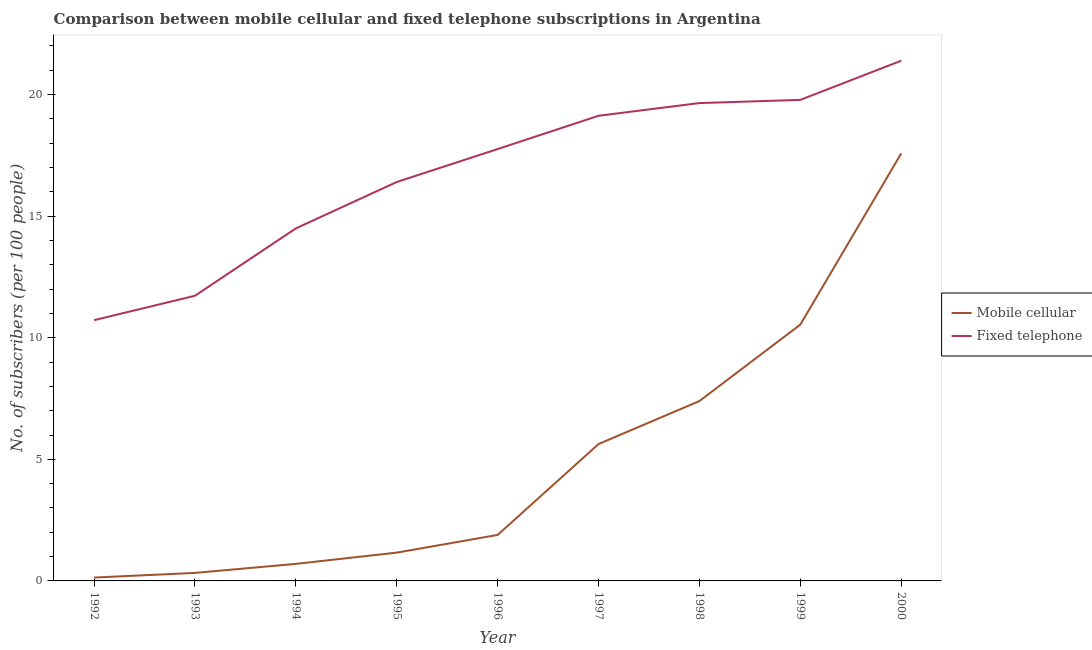What is the number of fixed telephone subscribers in 1998?
Your answer should be compact. 19.65. Across all years, what is the maximum number of mobile cellular subscribers?
Provide a short and direct response. 17.58. Across all years, what is the minimum number of fixed telephone subscribers?
Provide a short and direct response. 10.72. What is the total number of fixed telephone subscribers in the graph?
Keep it short and to the point. 151.06. What is the difference between the number of fixed telephone subscribers in 1992 and that in 1994?
Provide a short and direct response. -3.77. What is the difference between the number of mobile cellular subscribers in 1999 and the number of fixed telephone subscribers in 1995?
Provide a short and direct response. -5.86. What is the average number of fixed telephone subscribers per year?
Ensure brevity in your answer.  16.78. In the year 1996, what is the difference between the number of fixed telephone subscribers and number of mobile cellular subscribers?
Offer a very short reply. 15.87. In how many years, is the number of fixed telephone subscribers greater than 20?
Your response must be concise. 1. What is the ratio of the number of mobile cellular subscribers in 1996 to that in 1998?
Your response must be concise. 0.26. Is the number of mobile cellular subscribers in 1997 less than that in 1999?
Your response must be concise. Yes. Is the difference between the number of mobile cellular subscribers in 1992 and 1996 greater than the difference between the number of fixed telephone subscribers in 1992 and 1996?
Keep it short and to the point. Yes. What is the difference between the highest and the second highest number of fixed telephone subscribers?
Offer a terse response. 1.61. What is the difference between the highest and the lowest number of fixed telephone subscribers?
Make the answer very short. 10.67. In how many years, is the number of mobile cellular subscribers greater than the average number of mobile cellular subscribers taken over all years?
Your answer should be compact. 4. How many lines are there?
Give a very brief answer. 2. How many years are there in the graph?
Offer a terse response. 9. Are the values on the major ticks of Y-axis written in scientific E-notation?
Offer a terse response. No. Does the graph contain any zero values?
Offer a very short reply. No. How many legend labels are there?
Your answer should be compact. 2. What is the title of the graph?
Offer a terse response. Comparison between mobile cellular and fixed telephone subscriptions in Argentina. What is the label or title of the Y-axis?
Offer a terse response. No. of subscribers (per 100 people). What is the No. of subscribers (per 100 people) in Mobile cellular in 1992?
Provide a short and direct response. 0.14. What is the No. of subscribers (per 100 people) in Fixed telephone in 1992?
Offer a terse response. 10.72. What is the No. of subscribers (per 100 people) of Mobile cellular in 1993?
Your answer should be very brief. 0.33. What is the No. of subscribers (per 100 people) of Fixed telephone in 1993?
Your response must be concise. 11.73. What is the No. of subscribers (per 100 people) in Mobile cellular in 1994?
Make the answer very short. 0.7. What is the No. of subscribers (per 100 people) in Fixed telephone in 1994?
Give a very brief answer. 14.5. What is the No. of subscribers (per 100 people) of Mobile cellular in 1995?
Offer a terse response. 1.16. What is the No. of subscribers (per 100 people) of Fixed telephone in 1995?
Offer a very short reply. 16.4. What is the No. of subscribers (per 100 people) in Mobile cellular in 1996?
Your response must be concise. 1.89. What is the No. of subscribers (per 100 people) of Fixed telephone in 1996?
Your response must be concise. 17.76. What is the No. of subscribers (per 100 people) in Mobile cellular in 1997?
Ensure brevity in your answer.  5.63. What is the No. of subscribers (per 100 people) of Fixed telephone in 1997?
Provide a short and direct response. 19.13. What is the No. of subscribers (per 100 people) of Mobile cellular in 1998?
Offer a very short reply. 7.4. What is the No. of subscribers (per 100 people) in Fixed telephone in 1998?
Your answer should be compact. 19.65. What is the No. of subscribers (per 100 people) in Mobile cellular in 1999?
Provide a succinct answer. 10.54. What is the No. of subscribers (per 100 people) of Fixed telephone in 1999?
Offer a very short reply. 19.78. What is the No. of subscribers (per 100 people) in Mobile cellular in 2000?
Your answer should be compact. 17.58. What is the No. of subscribers (per 100 people) of Fixed telephone in 2000?
Your answer should be very brief. 21.39. Across all years, what is the maximum No. of subscribers (per 100 people) of Mobile cellular?
Your answer should be very brief. 17.58. Across all years, what is the maximum No. of subscribers (per 100 people) of Fixed telephone?
Make the answer very short. 21.39. Across all years, what is the minimum No. of subscribers (per 100 people) of Mobile cellular?
Your response must be concise. 0.14. Across all years, what is the minimum No. of subscribers (per 100 people) in Fixed telephone?
Keep it short and to the point. 10.72. What is the total No. of subscribers (per 100 people) in Mobile cellular in the graph?
Offer a terse response. 45.37. What is the total No. of subscribers (per 100 people) in Fixed telephone in the graph?
Your answer should be very brief. 151.06. What is the difference between the No. of subscribers (per 100 people) in Mobile cellular in 1992 and that in 1993?
Your response must be concise. -0.19. What is the difference between the No. of subscribers (per 100 people) of Fixed telephone in 1992 and that in 1993?
Give a very brief answer. -1. What is the difference between the No. of subscribers (per 100 people) in Mobile cellular in 1992 and that in 1994?
Your response must be concise. -0.56. What is the difference between the No. of subscribers (per 100 people) in Fixed telephone in 1992 and that in 1994?
Make the answer very short. -3.77. What is the difference between the No. of subscribers (per 100 people) in Mobile cellular in 1992 and that in 1995?
Offer a very short reply. -1.02. What is the difference between the No. of subscribers (per 100 people) in Fixed telephone in 1992 and that in 1995?
Make the answer very short. -5.68. What is the difference between the No. of subscribers (per 100 people) of Mobile cellular in 1992 and that in 1996?
Offer a terse response. -1.75. What is the difference between the No. of subscribers (per 100 people) of Fixed telephone in 1992 and that in 1996?
Offer a very short reply. -7.04. What is the difference between the No. of subscribers (per 100 people) of Mobile cellular in 1992 and that in 1997?
Keep it short and to the point. -5.49. What is the difference between the No. of subscribers (per 100 people) of Fixed telephone in 1992 and that in 1997?
Make the answer very short. -8.4. What is the difference between the No. of subscribers (per 100 people) in Mobile cellular in 1992 and that in 1998?
Your answer should be compact. -7.26. What is the difference between the No. of subscribers (per 100 people) of Fixed telephone in 1992 and that in 1998?
Make the answer very short. -8.93. What is the difference between the No. of subscribers (per 100 people) in Mobile cellular in 1992 and that in 1999?
Provide a succinct answer. -10.4. What is the difference between the No. of subscribers (per 100 people) of Fixed telephone in 1992 and that in 1999?
Your response must be concise. -9.06. What is the difference between the No. of subscribers (per 100 people) in Mobile cellular in 1992 and that in 2000?
Keep it short and to the point. -17.44. What is the difference between the No. of subscribers (per 100 people) in Fixed telephone in 1992 and that in 2000?
Provide a succinct answer. -10.67. What is the difference between the No. of subscribers (per 100 people) in Mobile cellular in 1993 and that in 1994?
Offer a very short reply. -0.37. What is the difference between the No. of subscribers (per 100 people) in Fixed telephone in 1993 and that in 1994?
Ensure brevity in your answer.  -2.77. What is the difference between the No. of subscribers (per 100 people) of Mobile cellular in 1993 and that in 1995?
Ensure brevity in your answer.  -0.83. What is the difference between the No. of subscribers (per 100 people) in Fixed telephone in 1993 and that in 1995?
Provide a short and direct response. -4.68. What is the difference between the No. of subscribers (per 100 people) of Mobile cellular in 1993 and that in 1996?
Your answer should be very brief. -1.56. What is the difference between the No. of subscribers (per 100 people) of Fixed telephone in 1993 and that in 1996?
Provide a succinct answer. -6.03. What is the difference between the No. of subscribers (per 100 people) of Mobile cellular in 1993 and that in 1997?
Provide a succinct answer. -5.3. What is the difference between the No. of subscribers (per 100 people) of Fixed telephone in 1993 and that in 1997?
Your answer should be compact. -7.4. What is the difference between the No. of subscribers (per 100 people) in Mobile cellular in 1993 and that in 1998?
Keep it short and to the point. -7.07. What is the difference between the No. of subscribers (per 100 people) of Fixed telephone in 1993 and that in 1998?
Provide a short and direct response. -7.92. What is the difference between the No. of subscribers (per 100 people) of Mobile cellular in 1993 and that in 1999?
Ensure brevity in your answer.  -10.21. What is the difference between the No. of subscribers (per 100 people) in Fixed telephone in 1993 and that in 1999?
Offer a terse response. -8.06. What is the difference between the No. of subscribers (per 100 people) in Mobile cellular in 1993 and that in 2000?
Ensure brevity in your answer.  -17.25. What is the difference between the No. of subscribers (per 100 people) of Fixed telephone in 1993 and that in 2000?
Your response must be concise. -9.67. What is the difference between the No. of subscribers (per 100 people) in Mobile cellular in 1994 and that in 1995?
Keep it short and to the point. -0.46. What is the difference between the No. of subscribers (per 100 people) of Fixed telephone in 1994 and that in 1995?
Your answer should be very brief. -1.91. What is the difference between the No. of subscribers (per 100 people) of Mobile cellular in 1994 and that in 1996?
Your answer should be very brief. -1.19. What is the difference between the No. of subscribers (per 100 people) in Fixed telephone in 1994 and that in 1996?
Provide a short and direct response. -3.26. What is the difference between the No. of subscribers (per 100 people) in Mobile cellular in 1994 and that in 1997?
Your response must be concise. -4.93. What is the difference between the No. of subscribers (per 100 people) of Fixed telephone in 1994 and that in 1997?
Your response must be concise. -4.63. What is the difference between the No. of subscribers (per 100 people) of Mobile cellular in 1994 and that in 1998?
Your answer should be very brief. -6.7. What is the difference between the No. of subscribers (per 100 people) of Fixed telephone in 1994 and that in 1998?
Your answer should be very brief. -5.15. What is the difference between the No. of subscribers (per 100 people) of Mobile cellular in 1994 and that in 1999?
Your answer should be compact. -9.84. What is the difference between the No. of subscribers (per 100 people) in Fixed telephone in 1994 and that in 1999?
Ensure brevity in your answer.  -5.28. What is the difference between the No. of subscribers (per 100 people) of Mobile cellular in 1994 and that in 2000?
Provide a short and direct response. -16.88. What is the difference between the No. of subscribers (per 100 people) of Fixed telephone in 1994 and that in 2000?
Keep it short and to the point. -6.89. What is the difference between the No. of subscribers (per 100 people) of Mobile cellular in 1995 and that in 1996?
Offer a terse response. -0.73. What is the difference between the No. of subscribers (per 100 people) of Fixed telephone in 1995 and that in 1996?
Your response must be concise. -1.35. What is the difference between the No. of subscribers (per 100 people) of Mobile cellular in 1995 and that in 1997?
Your answer should be very brief. -4.47. What is the difference between the No. of subscribers (per 100 people) in Fixed telephone in 1995 and that in 1997?
Provide a succinct answer. -2.72. What is the difference between the No. of subscribers (per 100 people) in Mobile cellular in 1995 and that in 1998?
Make the answer very short. -6.23. What is the difference between the No. of subscribers (per 100 people) of Fixed telephone in 1995 and that in 1998?
Keep it short and to the point. -3.25. What is the difference between the No. of subscribers (per 100 people) in Mobile cellular in 1995 and that in 1999?
Your answer should be very brief. -9.38. What is the difference between the No. of subscribers (per 100 people) in Fixed telephone in 1995 and that in 1999?
Keep it short and to the point. -3.38. What is the difference between the No. of subscribers (per 100 people) in Mobile cellular in 1995 and that in 2000?
Your answer should be very brief. -16.42. What is the difference between the No. of subscribers (per 100 people) of Fixed telephone in 1995 and that in 2000?
Ensure brevity in your answer.  -4.99. What is the difference between the No. of subscribers (per 100 people) in Mobile cellular in 1996 and that in 1997?
Offer a very short reply. -3.74. What is the difference between the No. of subscribers (per 100 people) of Fixed telephone in 1996 and that in 1997?
Give a very brief answer. -1.37. What is the difference between the No. of subscribers (per 100 people) of Mobile cellular in 1996 and that in 1998?
Your response must be concise. -5.51. What is the difference between the No. of subscribers (per 100 people) in Fixed telephone in 1996 and that in 1998?
Ensure brevity in your answer.  -1.89. What is the difference between the No. of subscribers (per 100 people) of Mobile cellular in 1996 and that in 1999?
Make the answer very short. -8.65. What is the difference between the No. of subscribers (per 100 people) in Fixed telephone in 1996 and that in 1999?
Make the answer very short. -2.02. What is the difference between the No. of subscribers (per 100 people) of Mobile cellular in 1996 and that in 2000?
Offer a terse response. -15.69. What is the difference between the No. of subscribers (per 100 people) in Fixed telephone in 1996 and that in 2000?
Give a very brief answer. -3.63. What is the difference between the No. of subscribers (per 100 people) of Mobile cellular in 1997 and that in 1998?
Give a very brief answer. -1.77. What is the difference between the No. of subscribers (per 100 people) in Fixed telephone in 1997 and that in 1998?
Your answer should be very brief. -0.52. What is the difference between the No. of subscribers (per 100 people) of Mobile cellular in 1997 and that in 1999?
Provide a succinct answer. -4.91. What is the difference between the No. of subscribers (per 100 people) in Fixed telephone in 1997 and that in 1999?
Make the answer very short. -0.65. What is the difference between the No. of subscribers (per 100 people) in Mobile cellular in 1997 and that in 2000?
Ensure brevity in your answer.  -11.95. What is the difference between the No. of subscribers (per 100 people) of Fixed telephone in 1997 and that in 2000?
Make the answer very short. -2.26. What is the difference between the No. of subscribers (per 100 people) of Mobile cellular in 1998 and that in 1999?
Keep it short and to the point. -3.14. What is the difference between the No. of subscribers (per 100 people) in Fixed telephone in 1998 and that in 1999?
Your response must be concise. -0.13. What is the difference between the No. of subscribers (per 100 people) of Mobile cellular in 1998 and that in 2000?
Your answer should be compact. -10.18. What is the difference between the No. of subscribers (per 100 people) of Fixed telephone in 1998 and that in 2000?
Make the answer very short. -1.74. What is the difference between the No. of subscribers (per 100 people) of Mobile cellular in 1999 and that in 2000?
Provide a short and direct response. -7.04. What is the difference between the No. of subscribers (per 100 people) in Fixed telephone in 1999 and that in 2000?
Give a very brief answer. -1.61. What is the difference between the No. of subscribers (per 100 people) of Mobile cellular in 1992 and the No. of subscribers (per 100 people) of Fixed telephone in 1993?
Offer a terse response. -11.59. What is the difference between the No. of subscribers (per 100 people) in Mobile cellular in 1992 and the No. of subscribers (per 100 people) in Fixed telephone in 1994?
Ensure brevity in your answer.  -14.36. What is the difference between the No. of subscribers (per 100 people) of Mobile cellular in 1992 and the No. of subscribers (per 100 people) of Fixed telephone in 1995?
Give a very brief answer. -16.27. What is the difference between the No. of subscribers (per 100 people) of Mobile cellular in 1992 and the No. of subscribers (per 100 people) of Fixed telephone in 1996?
Make the answer very short. -17.62. What is the difference between the No. of subscribers (per 100 people) of Mobile cellular in 1992 and the No. of subscribers (per 100 people) of Fixed telephone in 1997?
Your answer should be compact. -18.99. What is the difference between the No. of subscribers (per 100 people) of Mobile cellular in 1992 and the No. of subscribers (per 100 people) of Fixed telephone in 1998?
Offer a very short reply. -19.51. What is the difference between the No. of subscribers (per 100 people) of Mobile cellular in 1992 and the No. of subscribers (per 100 people) of Fixed telephone in 1999?
Keep it short and to the point. -19.64. What is the difference between the No. of subscribers (per 100 people) in Mobile cellular in 1992 and the No. of subscribers (per 100 people) in Fixed telephone in 2000?
Your response must be concise. -21.25. What is the difference between the No. of subscribers (per 100 people) in Mobile cellular in 1993 and the No. of subscribers (per 100 people) in Fixed telephone in 1994?
Your answer should be compact. -14.17. What is the difference between the No. of subscribers (per 100 people) of Mobile cellular in 1993 and the No. of subscribers (per 100 people) of Fixed telephone in 1995?
Give a very brief answer. -16.07. What is the difference between the No. of subscribers (per 100 people) of Mobile cellular in 1993 and the No. of subscribers (per 100 people) of Fixed telephone in 1996?
Keep it short and to the point. -17.43. What is the difference between the No. of subscribers (per 100 people) of Mobile cellular in 1993 and the No. of subscribers (per 100 people) of Fixed telephone in 1997?
Ensure brevity in your answer.  -18.8. What is the difference between the No. of subscribers (per 100 people) of Mobile cellular in 1993 and the No. of subscribers (per 100 people) of Fixed telephone in 1998?
Make the answer very short. -19.32. What is the difference between the No. of subscribers (per 100 people) of Mobile cellular in 1993 and the No. of subscribers (per 100 people) of Fixed telephone in 1999?
Provide a short and direct response. -19.45. What is the difference between the No. of subscribers (per 100 people) of Mobile cellular in 1993 and the No. of subscribers (per 100 people) of Fixed telephone in 2000?
Give a very brief answer. -21.06. What is the difference between the No. of subscribers (per 100 people) in Mobile cellular in 1994 and the No. of subscribers (per 100 people) in Fixed telephone in 1995?
Ensure brevity in your answer.  -15.7. What is the difference between the No. of subscribers (per 100 people) in Mobile cellular in 1994 and the No. of subscribers (per 100 people) in Fixed telephone in 1996?
Keep it short and to the point. -17.06. What is the difference between the No. of subscribers (per 100 people) of Mobile cellular in 1994 and the No. of subscribers (per 100 people) of Fixed telephone in 1997?
Make the answer very short. -18.43. What is the difference between the No. of subscribers (per 100 people) of Mobile cellular in 1994 and the No. of subscribers (per 100 people) of Fixed telephone in 1998?
Provide a short and direct response. -18.95. What is the difference between the No. of subscribers (per 100 people) of Mobile cellular in 1994 and the No. of subscribers (per 100 people) of Fixed telephone in 1999?
Ensure brevity in your answer.  -19.08. What is the difference between the No. of subscribers (per 100 people) in Mobile cellular in 1994 and the No. of subscribers (per 100 people) in Fixed telephone in 2000?
Make the answer very short. -20.69. What is the difference between the No. of subscribers (per 100 people) in Mobile cellular in 1995 and the No. of subscribers (per 100 people) in Fixed telephone in 1996?
Your answer should be very brief. -16.6. What is the difference between the No. of subscribers (per 100 people) of Mobile cellular in 1995 and the No. of subscribers (per 100 people) of Fixed telephone in 1997?
Your answer should be very brief. -17.96. What is the difference between the No. of subscribers (per 100 people) in Mobile cellular in 1995 and the No. of subscribers (per 100 people) in Fixed telephone in 1998?
Offer a terse response. -18.49. What is the difference between the No. of subscribers (per 100 people) in Mobile cellular in 1995 and the No. of subscribers (per 100 people) in Fixed telephone in 1999?
Provide a short and direct response. -18.62. What is the difference between the No. of subscribers (per 100 people) in Mobile cellular in 1995 and the No. of subscribers (per 100 people) in Fixed telephone in 2000?
Provide a short and direct response. -20.23. What is the difference between the No. of subscribers (per 100 people) of Mobile cellular in 1996 and the No. of subscribers (per 100 people) of Fixed telephone in 1997?
Keep it short and to the point. -17.24. What is the difference between the No. of subscribers (per 100 people) in Mobile cellular in 1996 and the No. of subscribers (per 100 people) in Fixed telephone in 1998?
Make the answer very short. -17.76. What is the difference between the No. of subscribers (per 100 people) of Mobile cellular in 1996 and the No. of subscribers (per 100 people) of Fixed telephone in 1999?
Your answer should be very brief. -17.89. What is the difference between the No. of subscribers (per 100 people) of Mobile cellular in 1996 and the No. of subscribers (per 100 people) of Fixed telephone in 2000?
Your response must be concise. -19.5. What is the difference between the No. of subscribers (per 100 people) of Mobile cellular in 1997 and the No. of subscribers (per 100 people) of Fixed telephone in 1998?
Provide a short and direct response. -14.02. What is the difference between the No. of subscribers (per 100 people) in Mobile cellular in 1997 and the No. of subscribers (per 100 people) in Fixed telephone in 1999?
Offer a very short reply. -14.15. What is the difference between the No. of subscribers (per 100 people) in Mobile cellular in 1997 and the No. of subscribers (per 100 people) in Fixed telephone in 2000?
Your answer should be very brief. -15.76. What is the difference between the No. of subscribers (per 100 people) in Mobile cellular in 1998 and the No. of subscribers (per 100 people) in Fixed telephone in 1999?
Keep it short and to the point. -12.38. What is the difference between the No. of subscribers (per 100 people) of Mobile cellular in 1998 and the No. of subscribers (per 100 people) of Fixed telephone in 2000?
Your response must be concise. -14. What is the difference between the No. of subscribers (per 100 people) of Mobile cellular in 1999 and the No. of subscribers (per 100 people) of Fixed telephone in 2000?
Provide a short and direct response. -10.85. What is the average No. of subscribers (per 100 people) of Mobile cellular per year?
Offer a terse response. 5.04. What is the average No. of subscribers (per 100 people) of Fixed telephone per year?
Offer a very short reply. 16.78. In the year 1992, what is the difference between the No. of subscribers (per 100 people) of Mobile cellular and No. of subscribers (per 100 people) of Fixed telephone?
Your response must be concise. -10.58. In the year 1993, what is the difference between the No. of subscribers (per 100 people) in Mobile cellular and No. of subscribers (per 100 people) in Fixed telephone?
Give a very brief answer. -11.4. In the year 1994, what is the difference between the No. of subscribers (per 100 people) in Mobile cellular and No. of subscribers (per 100 people) in Fixed telephone?
Your answer should be compact. -13.8. In the year 1995, what is the difference between the No. of subscribers (per 100 people) of Mobile cellular and No. of subscribers (per 100 people) of Fixed telephone?
Your answer should be very brief. -15.24. In the year 1996, what is the difference between the No. of subscribers (per 100 people) in Mobile cellular and No. of subscribers (per 100 people) in Fixed telephone?
Keep it short and to the point. -15.87. In the year 1997, what is the difference between the No. of subscribers (per 100 people) of Mobile cellular and No. of subscribers (per 100 people) of Fixed telephone?
Provide a short and direct response. -13.5. In the year 1998, what is the difference between the No. of subscribers (per 100 people) in Mobile cellular and No. of subscribers (per 100 people) in Fixed telephone?
Offer a very short reply. -12.25. In the year 1999, what is the difference between the No. of subscribers (per 100 people) in Mobile cellular and No. of subscribers (per 100 people) in Fixed telephone?
Provide a succinct answer. -9.24. In the year 2000, what is the difference between the No. of subscribers (per 100 people) in Mobile cellular and No. of subscribers (per 100 people) in Fixed telephone?
Your answer should be compact. -3.81. What is the ratio of the No. of subscribers (per 100 people) of Mobile cellular in 1992 to that in 1993?
Offer a very short reply. 0.42. What is the ratio of the No. of subscribers (per 100 people) of Fixed telephone in 1992 to that in 1993?
Provide a succinct answer. 0.91. What is the ratio of the No. of subscribers (per 100 people) of Mobile cellular in 1992 to that in 1994?
Provide a short and direct response. 0.2. What is the ratio of the No. of subscribers (per 100 people) in Fixed telephone in 1992 to that in 1994?
Make the answer very short. 0.74. What is the ratio of the No. of subscribers (per 100 people) of Mobile cellular in 1992 to that in 1995?
Your response must be concise. 0.12. What is the ratio of the No. of subscribers (per 100 people) of Fixed telephone in 1992 to that in 1995?
Keep it short and to the point. 0.65. What is the ratio of the No. of subscribers (per 100 people) of Mobile cellular in 1992 to that in 1996?
Your answer should be compact. 0.07. What is the ratio of the No. of subscribers (per 100 people) in Fixed telephone in 1992 to that in 1996?
Offer a very short reply. 0.6. What is the ratio of the No. of subscribers (per 100 people) of Mobile cellular in 1992 to that in 1997?
Ensure brevity in your answer.  0.02. What is the ratio of the No. of subscribers (per 100 people) of Fixed telephone in 1992 to that in 1997?
Your response must be concise. 0.56. What is the ratio of the No. of subscribers (per 100 people) of Mobile cellular in 1992 to that in 1998?
Provide a succinct answer. 0.02. What is the ratio of the No. of subscribers (per 100 people) in Fixed telephone in 1992 to that in 1998?
Provide a succinct answer. 0.55. What is the ratio of the No. of subscribers (per 100 people) of Mobile cellular in 1992 to that in 1999?
Your response must be concise. 0.01. What is the ratio of the No. of subscribers (per 100 people) in Fixed telephone in 1992 to that in 1999?
Provide a short and direct response. 0.54. What is the ratio of the No. of subscribers (per 100 people) of Mobile cellular in 1992 to that in 2000?
Your answer should be compact. 0.01. What is the ratio of the No. of subscribers (per 100 people) of Fixed telephone in 1992 to that in 2000?
Your answer should be compact. 0.5. What is the ratio of the No. of subscribers (per 100 people) in Mobile cellular in 1993 to that in 1994?
Offer a terse response. 0.47. What is the ratio of the No. of subscribers (per 100 people) in Fixed telephone in 1993 to that in 1994?
Give a very brief answer. 0.81. What is the ratio of the No. of subscribers (per 100 people) in Mobile cellular in 1993 to that in 1995?
Your answer should be compact. 0.28. What is the ratio of the No. of subscribers (per 100 people) in Fixed telephone in 1993 to that in 1995?
Offer a terse response. 0.71. What is the ratio of the No. of subscribers (per 100 people) in Mobile cellular in 1993 to that in 1996?
Offer a terse response. 0.17. What is the ratio of the No. of subscribers (per 100 people) in Fixed telephone in 1993 to that in 1996?
Provide a short and direct response. 0.66. What is the ratio of the No. of subscribers (per 100 people) in Mobile cellular in 1993 to that in 1997?
Make the answer very short. 0.06. What is the ratio of the No. of subscribers (per 100 people) in Fixed telephone in 1993 to that in 1997?
Your answer should be very brief. 0.61. What is the ratio of the No. of subscribers (per 100 people) of Mobile cellular in 1993 to that in 1998?
Offer a very short reply. 0.04. What is the ratio of the No. of subscribers (per 100 people) of Fixed telephone in 1993 to that in 1998?
Offer a terse response. 0.6. What is the ratio of the No. of subscribers (per 100 people) of Mobile cellular in 1993 to that in 1999?
Provide a succinct answer. 0.03. What is the ratio of the No. of subscribers (per 100 people) in Fixed telephone in 1993 to that in 1999?
Ensure brevity in your answer.  0.59. What is the ratio of the No. of subscribers (per 100 people) in Mobile cellular in 1993 to that in 2000?
Make the answer very short. 0.02. What is the ratio of the No. of subscribers (per 100 people) of Fixed telephone in 1993 to that in 2000?
Keep it short and to the point. 0.55. What is the ratio of the No. of subscribers (per 100 people) in Mobile cellular in 1994 to that in 1995?
Your answer should be very brief. 0.6. What is the ratio of the No. of subscribers (per 100 people) of Fixed telephone in 1994 to that in 1995?
Ensure brevity in your answer.  0.88. What is the ratio of the No. of subscribers (per 100 people) in Mobile cellular in 1994 to that in 1996?
Provide a succinct answer. 0.37. What is the ratio of the No. of subscribers (per 100 people) of Fixed telephone in 1994 to that in 1996?
Make the answer very short. 0.82. What is the ratio of the No. of subscribers (per 100 people) in Mobile cellular in 1994 to that in 1997?
Make the answer very short. 0.12. What is the ratio of the No. of subscribers (per 100 people) in Fixed telephone in 1994 to that in 1997?
Provide a short and direct response. 0.76. What is the ratio of the No. of subscribers (per 100 people) in Mobile cellular in 1994 to that in 1998?
Give a very brief answer. 0.09. What is the ratio of the No. of subscribers (per 100 people) of Fixed telephone in 1994 to that in 1998?
Your response must be concise. 0.74. What is the ratio of the No. of subscribers (per 100 people) in Mobile cellular in 1994 to that in 1999?
Give a very brief answer. 0.07. What is the ratio of the No. of subscribers (per 100 people) in Fixed telephone in 1994 to that in 1999?
Give a very brief answer. 0.73. What is the ratio of the No. of subscribers (per 100 people) in Mobile cellular in 1994 to that in 2000?
Your response must be concise. 0.04. What is the ratio of the No. of subscribers (per 100 people) in Fixed telephone in 1994 to that in 2000?
Keep it short and to the point. 0.68. What is the ratio of the No. of subscribers (per 100 people) of Mobile cellular in 1995 to that in 1996?
Offer a very short reply. 0.62. What is the ratio of the No. of subscribers (per 100 people) of Fixed telephone in 1995 to that in 1996?
Offer a very short reply. 0.92. What is the ratio of the No. of subscribers (per 100 people) in Mobile cellular in 1995 to that in 1997?
Offer a terse response. 0.21. What is the ratio of the No. of subscribers (per 100 people) of Fixed telephone in 1995 to that in 1997?
Provide a short and direct response. 0.86. What is the ratio of the No. of subscribers (per 100 people) in Mobile cellular in 1995 to that in 1998?
Your answer should be compact. 0.16. What is the ratio of the No. of subscribers (per 100 people) in Fixed telephone in 1995 to that in 1998?
Ensure brevity in your answer.  0.83. What is the ratio of the No. of subscribers (per 100 people) of Mobile cellular in 1995 to that in 1999?
Offer a very short reply. 0.11. What is the ratio of the No. of subscribers (per 100 people) of Fixed telephone in 1995 to that in 1999?
Offer a very short reply. 0.83. What is the ratio of the No. of subscribers (per 100 people) of Mobile cellular in 1995 to that in 2000?
Your answer should be very brief. 0.07. What is the ratio of the No. of subscribers (per 100 people) of Fixed telephone in 1995 to that in 2000?
Ensure brevity in your answer.  0.77. What is the ratio of the No. of subscribers (per 100 people) of Mobile cellular in 1996 to that in 1997?
Your answer should be very brief. 0.34. What is the ratio of the No. of subscribers (per 100 people) in Fixed telephone in 1996 to that in 1997?
Your response must be concise. 0.93. What is the ratio of the No. of subscribers (per 100 people) of Mobile cellular in 1996 to that in 1998?
Keep it short and to the point. 0.26. What is the ratio of the No. of subscribers (per 100 people) in Fixed telephone in 1996 to that in 1998?
Offer a very short reply. 0.9. What is the ratio of the No. of subscribers (per 100 people) of Mobile cellular in 1996 to that in 1999?
Provide a succinct answer. 0.18. What is the ratio of the No. of subscribers (per 100 people) of Fixed telephone in 1996 to that in 1999?
Give a very brief answer. 0.9. What is the ratio of the No. of subscribers (per 100 people) of Mobile cellular in 1996 to that in 2000?
Give a very brief answer. 0.11. What is the ratio of the No. of subscribers (per 100 people) in Fixed telephone in 1996 to that in 2000?
Your answer should be very brief. 0.83. What is the ratio of the No. of subscribers (per 100 people) of Mobile cellular in 1997 to that in 1998?
Provide a succinct answer. 0.76. What is the ratio of the No. of subscribers (per 100 people) in Fixed telephone in 1997 to that in 1998?
Ensure brevity in your answer.  0.97. What is the ratio of the No. of subscribers (per 100 people) in Mobile cellular in 1997 to that in 1999?
Provide a succinct answer. 0.53. What is the ratio of the No. of subscribers (per 100 people) in Fixed telephone in 1997 to that in 1999?
Your answer should be very brief. 0.97. What is the ratio of the No. of subscribers (per 100 people) in Mobile cellular in 1997 to that in 2000?
Your answer should be very brief. 0.32. What is the ratio of the No. of subscribers (per 100 people) of Fixed telephone in 1997 to that in 2000?
Keep it short and to the point. 0.89. What is the ratio of the No. of subscribers (per 100 people) in Mobile cellular in 1998 to that in 1999?
Make the answer very short. 0.7. What is the ratio of the No. of subscribers (per 100 people) of Mobile cellular in 1998 to that in 2000?
Keep it short and to the point. 0.42. What is the ratio of the No. of subscribers (per 100 people) in Fixed telephone in 1998 to that in 2000?
Ensure brevity in your answer.  0.92. What is the ratio of the No. of subscribers (per 100 people) of Mobile cellular in 1999 to that in 2000?
Provide a short and direct response. 0.6. What is the ratio of the No. of subscribers (per 100 people) in Fixed telephone in 1999 to that in 2000?
Offer a very short reply. 0.92. What is the difference between the highest and the second highest No. of subscribers (per 100 people) in Mobile cellular?
Provide a succinct answer. 7.04. What is the difference between the highest and the second highest No. of subscribers (per 100 people) in Fixed telephone?
Your answer should be very brief. 1.61. What is the difference between the highest and the lowest No. of subscribers (per 100 people) in Mobile cellular?
Your answer should be compact. 17.44. What is the difference between the highest and the lowest No. of subscribers (per 100 people) in Fixed telephone?
Offer a terse response. 10.67. 